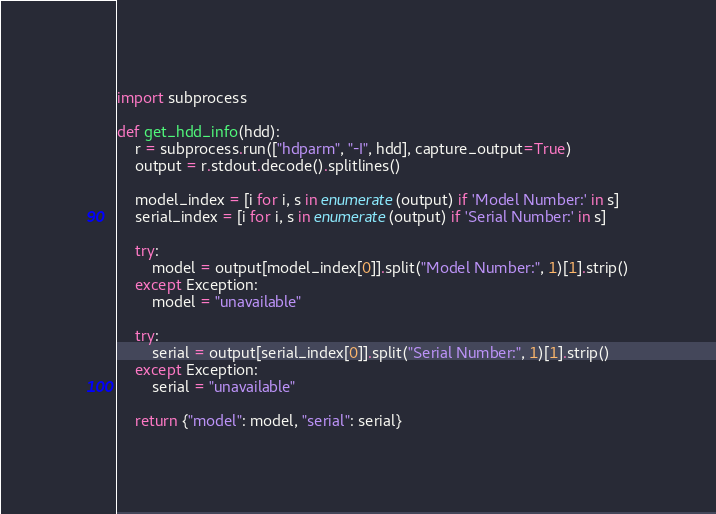<code> <loc_0><loc_0><loc_500><loc_500><_Python_>import subprocess

def get_hdd_info(hdd):
    r = subprocess.run(["hdparm", "-I", hdd], capture_output=True)
    output = r.stdout.decode().splitlines()

    model_index = [i for i, s in enumerate(output) if 'Model Number:' in s]
    serial_index = [i for i, s in enumerate(output) if 'Serial Number:' in s]

    try:
        model = output[model_index[0]].split("Model Number:", 1)[1].strip()
    except Exception:
        model = "unavailable"
    
    try:
        serial = output[serial_index[0]].split("Serial Number:", 1)[1].strip()
    except Exception:
        serial = "unavailable"
    
    return {"model": model, "serial": serial}
</code> 